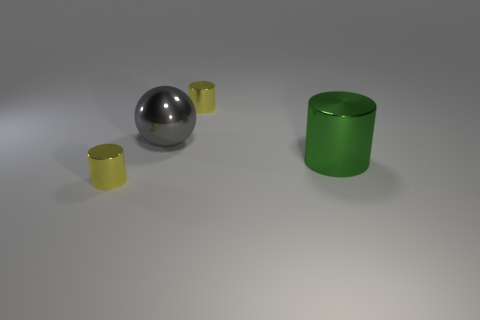Do the gray metal object and the small metal object that is in front of the green cylinder have the same shape?
Provide a succinct answer. No. Are there an equal number of metal cylinders in front of the big ball and green things behind the big green object?
Your answer should be compact. No. What number of other objects are the same material as the big cylinder?
Your answer should be compact. 3. How many matte objects are either big gray spheres or green objects?
Provide a short and direct response. 0. There is a small yellow shiny thing in front of the green shiny thing; is its shape the same as the large green object?
Give a very brief answer. Yes. Are there more gray objects that are on the left side of the large gray shiny object than tiny cylinders?
Provide a succinct answer. No. What number of cylinders are both in front of the big gray shiny ball and on the left side of the green shiny object?
Ensure brevity in your answer.  1. The cylinder in front of the large green metallic cylinder in front of the large ball is what color?
Your response must be concise. Yellow. How many big metal cylinders have the same color as the sphere?
Provide a short and direct response. 0. Is the color of the big metallic sphere the same as the cylinder that is to the left of the large gray sphere?
Your response must be concise. No. 